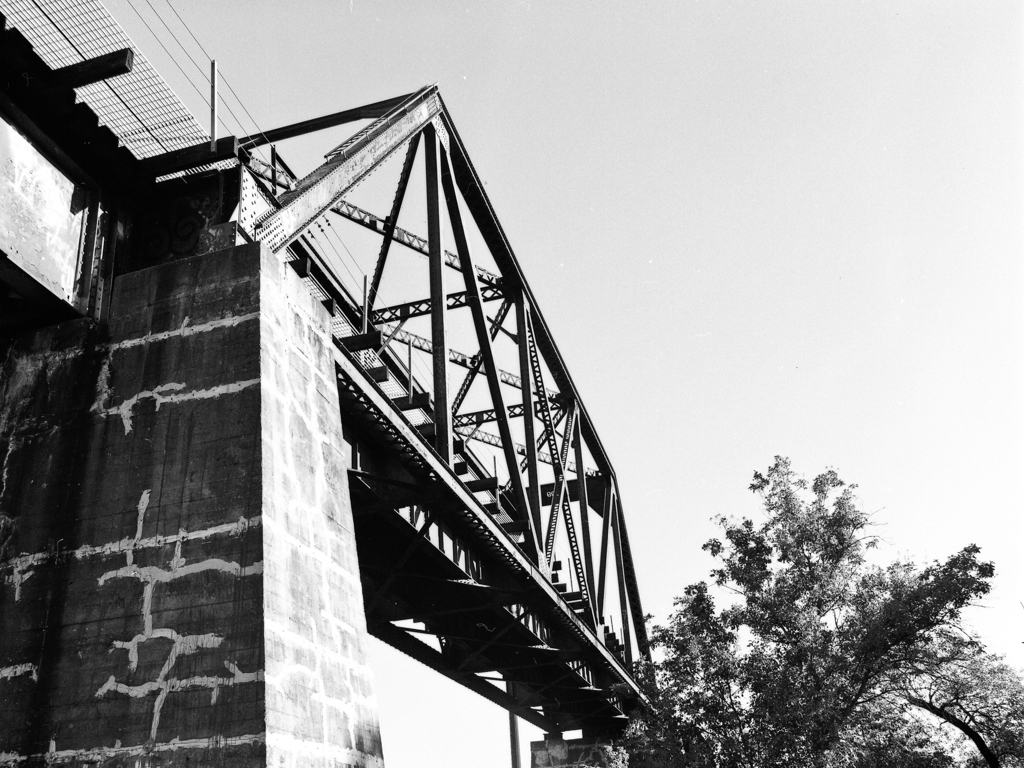What kind of area does this bridge connect? Is it more urban or rural? Based on the surroundings visible in the image, with nature elements like trees, and the absence of visible dense construction or buildings, it suggests that the bridge may be in a more rural or possibly suburban setting. Bridges in such areas often connect smaller communities or facilitate travel over natural obstacles like rivers or valleys. 